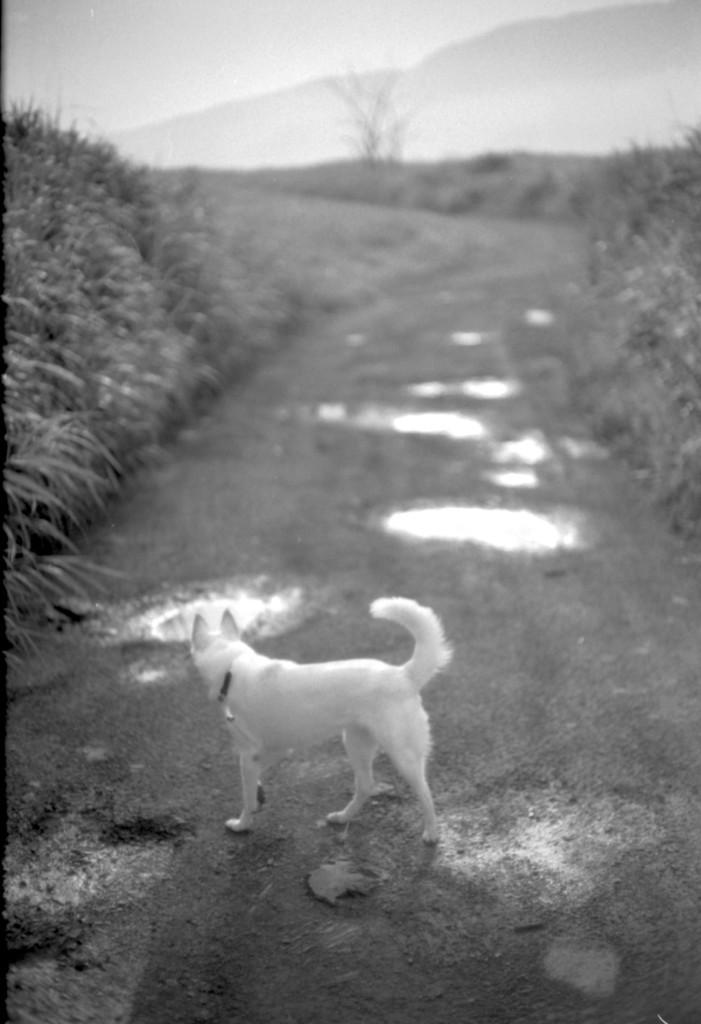What is the color scheme of the image? The image is black and white. What animal can be seen on the ground in the image? There is a dog on the ground in the image. What natural element is visible in the image? There is water visible in the image. What type of vegetation is present in the image? There are plants and trees in the image. How would you describe the sky in the image? The sky is visible in the image and appears cloudy. What type of system is being used to produce the clouds in the image? There is no indication in the image that a system is being used to produce the clouds; they are a natural weather phenomenon. Can you see any blades in the image? There are no blades visible in the image. 